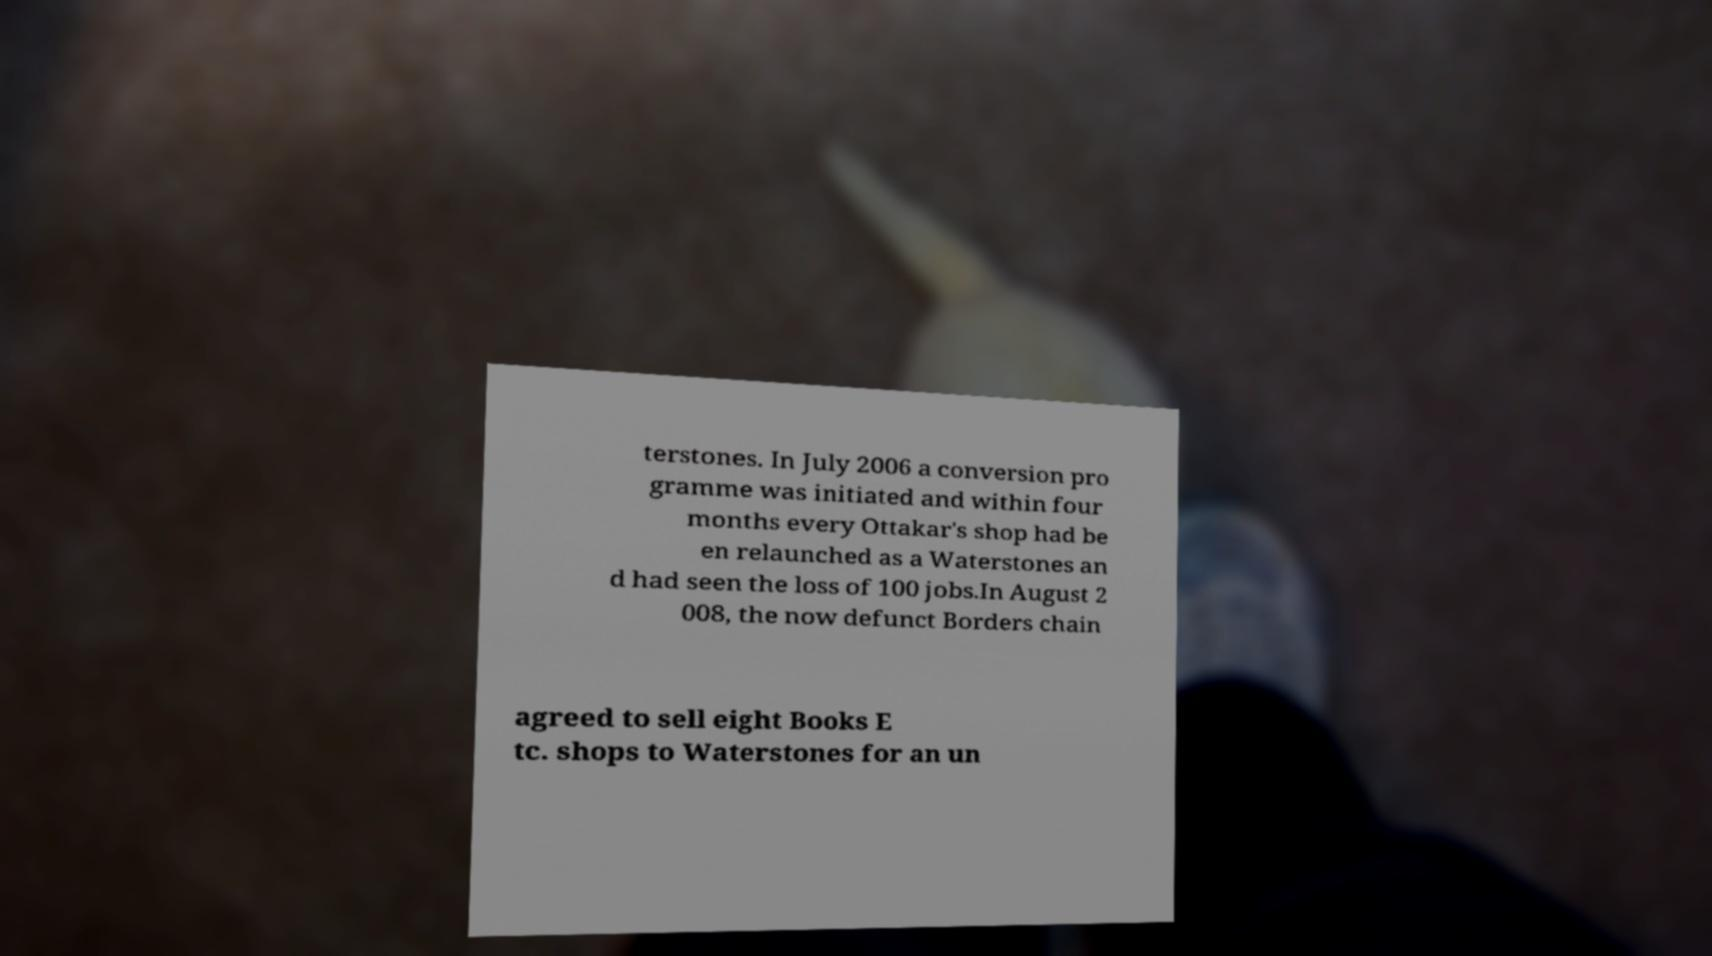For documentation purposes, I need the text within this image transcribed. Could you provide that? terstones. In July 2006 a conversion pro gramme was initiated and within four months every Ottakar's shop had be en relaunched as a Waterstones an d had seen the loss of 100 jobs.In August 2 008, the now defunct Borders chain agreed to sell eight Books E tc. shops to Waterstones for an un 